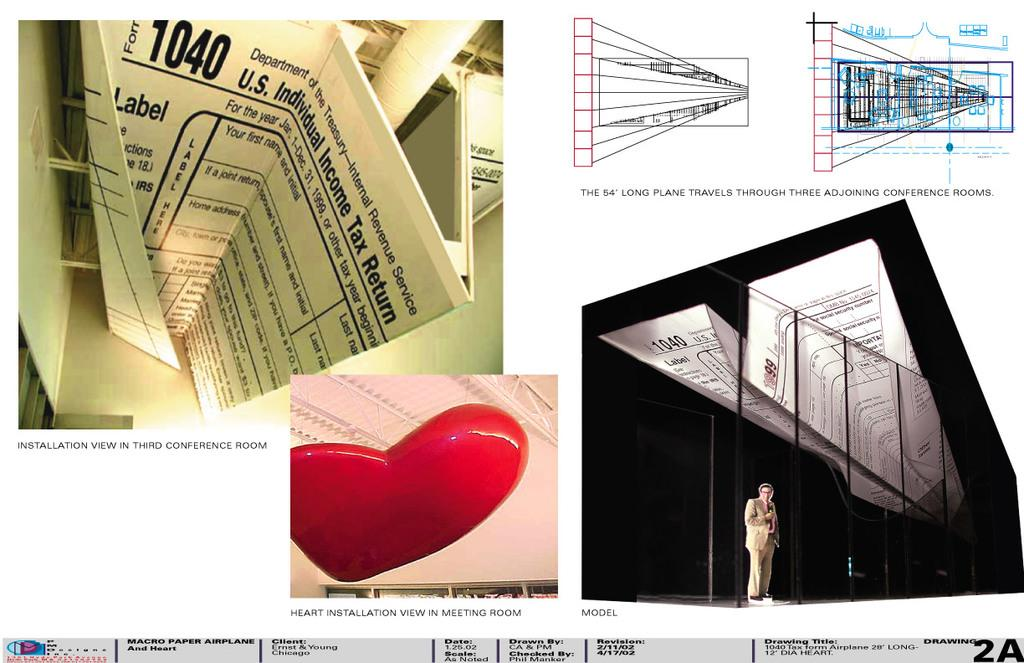<image>
Describe the image concisely. Several 1040 US tax return forms on shown in a display 